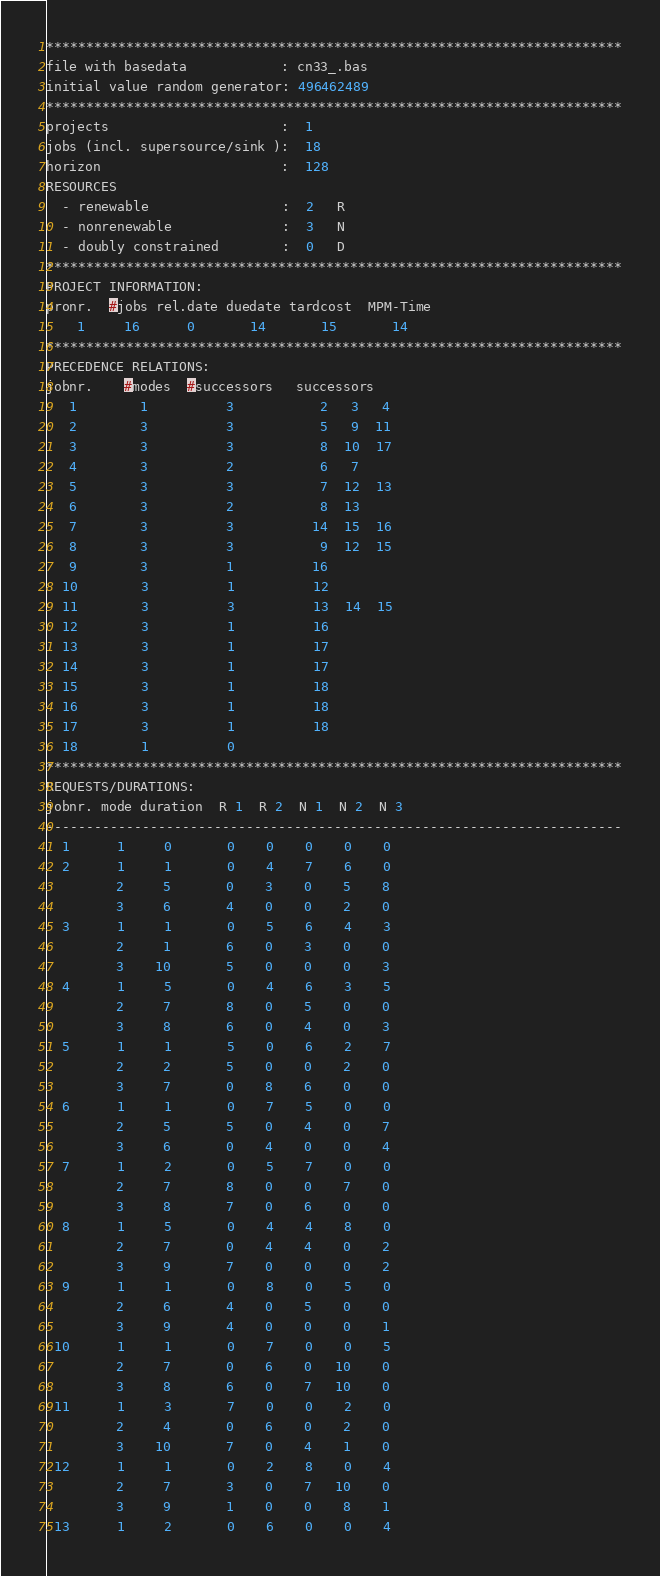<code> <loc_0><loc_0><loc_500><loc_500><_ObjectiveC_>************************************************************************
file with basedata            : cn33_.bas
initial value random generator: 496462489
************************************************************************
projects                      :  1
jobs (incl. supersource/sink ):  18
horizon                       :  128
RESOURCES
  - renewable                 :  2   R
  - nonrenewable              :  3   N
  - doubly constrained        :  0   D
************************************************************************
PROJECT INFORMATION:
pronr.  #jobs rel.date duedate tardcost  MPM-Time
    1     16      0       14       15       14
************************************************************************
PRECEDENCE RELATIONS:
jobnr.    #modes  #successors   successors
   1        1          3           2   3   4
   2        3          3           5   9  11
   3        3          3           8  10  17
   4        3          2           6   7
   5        3          3           7  12  13
   6        3          2           8  13
   7        3          3          14  15  16
   8        3          3           9  12  15
   9        3          1          16
  10        3          1          12
  11        3          3          13  14  15
  12        3          1          16
  13        3          1          17
  14        3          1          17
  15        3          1          18
  16        3          1          18
  17        3          1          18
  18        1          0        
************************************************************************
REQUESTS/DURATIONS:
jobnr. mode duration  R 1  R 2  N 1  N 2  N 3
------------------------------------------------------------------------
  1      1     0       0    0    0    0    0
  2      1     1       0    4    7    6    0
         2     5       0    3    0    5    8
         3     6       4    0    0    2    0
  3      1     1       0    5    6    4    3
         2     1       6    0    3    0    0
         3    10       5    0    0    0    3
  4      1     5       0    4    6    3    5
         2     7       8    0    5    0    0
         3     8       6    0    4    0    3
  5      1     1       5    0    6    2    7
         2     2       5    0    0    2    0
         3     7       0    8    6    0    0
  6      1     1       0    7    5    0    0
         2     5       5    0    4    0    7
         3     6       0    4    0    0    4
  7      1     2       0    5    7    0    0
         2     7       8    0    0    7    0
         3     8       7    0    6    0    0
  8      1     5       0    4    4    8    0
         2     7       0    4    4    0    2
         3     9       7    0    0    0    2
  9      1     1       0    8    0    5    0
         2     6       4    0    5    0    0
         3     9       4    0    0    0    1
 10      1     1       0    7    0    0    5
         2     7       0    6    0   10    0
         3     8       6    0    7   10    0
 11      1     3       7    0    0    2    0
         2     4       0    6    0    2    0
         3    10       7    0    4    1    0
 12      1     1       0    2    8    0    4
         2     7       3    0    7   10    0
         3     9       1    0    0    8    1
 13      1     2       0    6    0    0    4</code> 